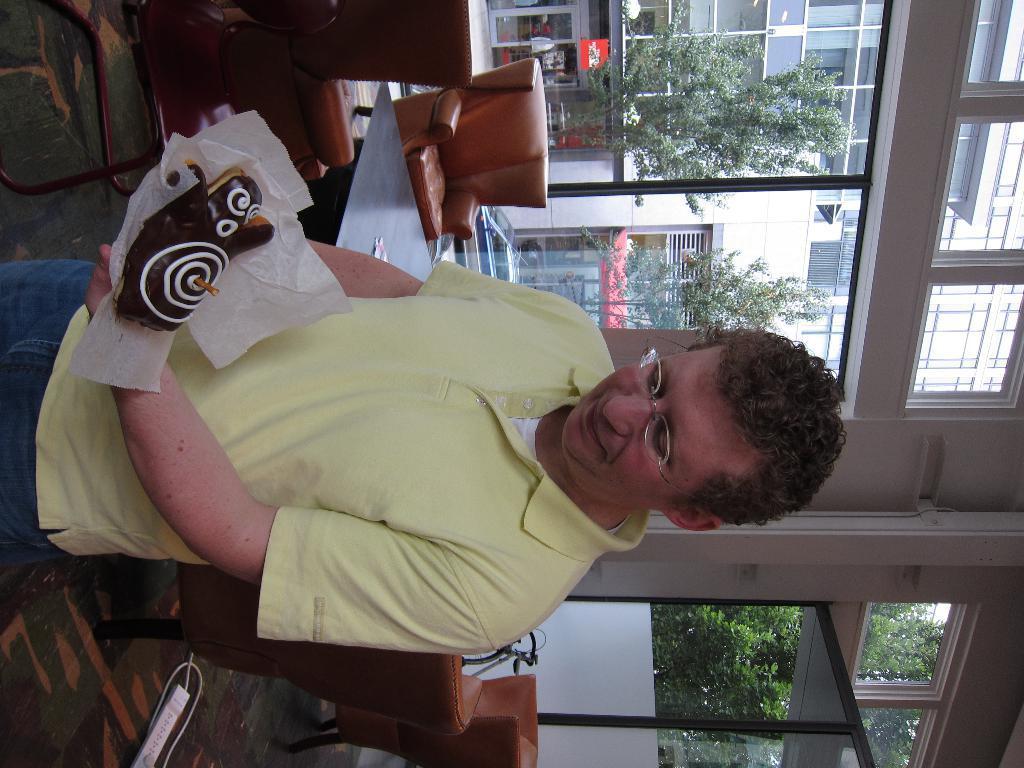Please provide a concise description of this image. In this image, we can see a person holding a food item and in the background, there are trees, buildings, chairs, table, windows. 